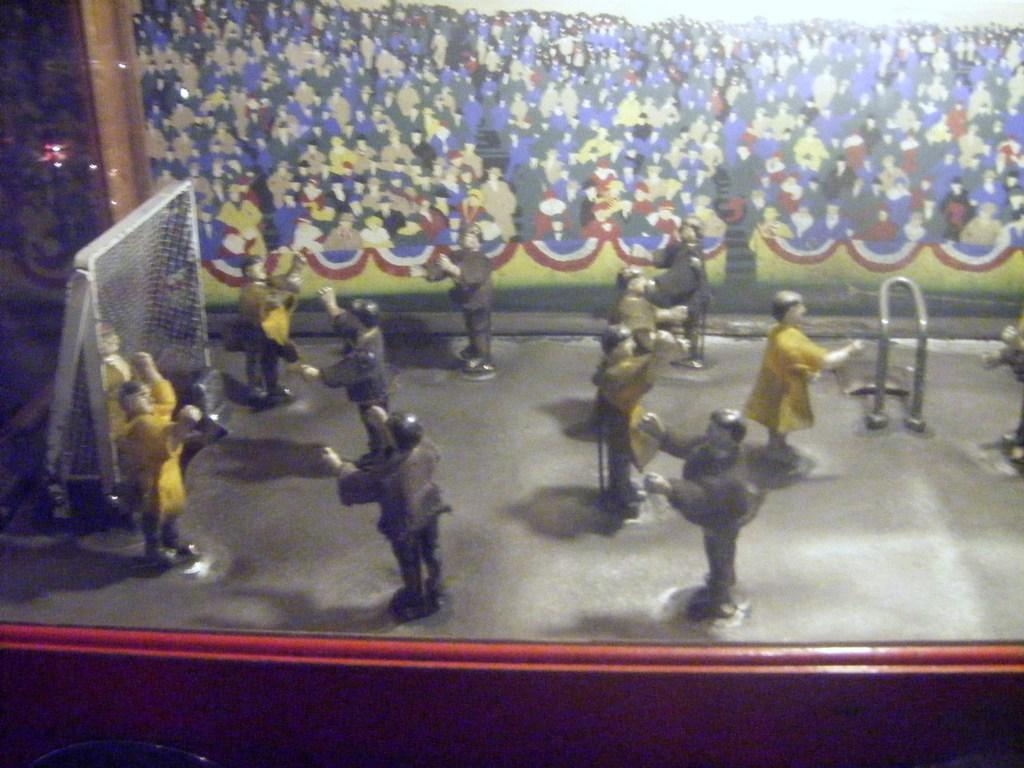What objects are present in the image? There are toys in the image. Where is the net located in the image? The net is in the left corner of the image. What can be seen in the background of the image? There is a painting in the background of the image. What type of food is being served by the committee in the image? There is no committee or food present in the image; it features toys, a net, and a painting. 